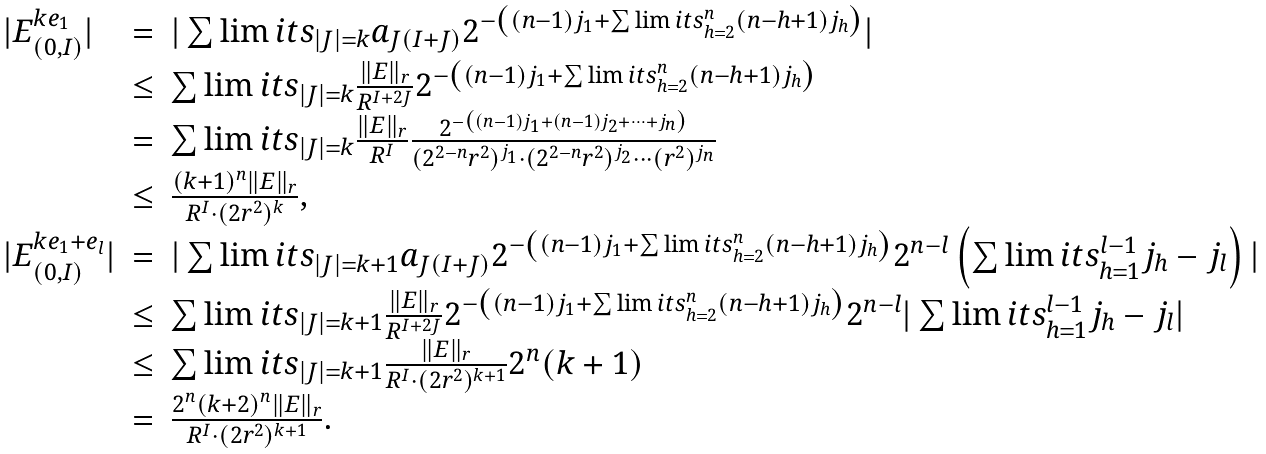Convert formula to latex. <formula><loc_0><loc_0><loc_500><loc_500>\begin{array} { l l l } | E _ { ( 0 , I ) } ^ { k e _ { 1 } } | & = & | \sum \lim i t s _ { | J | = k } a _ { J ( I + J ) } 2 ^ { - \left ( ( n - 1 ) j _ { 1 } + \sum \lim i t s _ { h = 2 } ^ { n } ( n - h + 1 ) j _ { h } \right ) } | \\ & \leq & \sum \lim i t s _ { | J | = k } \frac { \| E \| _ { r } } { R ^ { I + 2 J } } 2 ^ { - \left ( ( n - 1 ) j _ { 1 } + \sum \lim i t s _ { h = 2 } ^ { n } ( n - h + 1 ) j _ { h } \right ) } \\ & = & \sum \lim i t s _ { | J | = k } \frac { \| E \| _ { r } } { R ^ { I } } \frac { 2 ^ { - \left ( ( n - 1 ) j _ { 1 } + ( n - 1 ) j _ { 2 } + \cdots + j _ { n } \right ) } } { ( 2 ^ { 2 - n } r ^ { 2 } ) ^ { j _ { 1 } } \cdot ( 2 ^ { 2 - n } r ^ { 2 } ) ^ { j _ { 2 } } \cdots ( r ^ { 2 } ) ^ { j _ { n } } } \\ & \leq & \frac { ( k + 1 ) ^ { n } \| E \| _ { r } } { R ^ { I } \cdot ( 2 r ^ { 2 } ) ^ { k } } , \\ | E _ { ( 0 , I ) } ^ { k e _ { 1 } + e _ { l } } | & = & | \sum \lim i t s _ { | J | = k + 1 } a _ { J ( I + J ) } 2 ^ { - \left ( ( n - 1 ) j _ { 1 } + \sum \lim i t s _ { h = 2 } ^ { n } ( n - h + 1 ) j _ { h } \right ) } 2 ^ { n - l } \left ( \sum \lim i t s _ { h = 1 } ^ { l - 1 } j _ { h } - j _ { l } \right ) | \\ & \leq & \sum \lim i t s _ { | J | = k + 1 } \frac { \| E \| _ { r } } { R ^ { I + 2 J } } 2 ^ { - \left ( ( n - 1 ) j _ { 1 } + \sum \lim i t s _ { h = 2 } ^ { n } ( n - h + 1 ) j _ { h } \right ) } 2 ^ { n - l } | \sum \lim i t s _ { h = 1 } ^ { l - 1 } j _ { h } - j _ { l } | \\ & \leq & \sum \lim i t s _ { | J | = k + 1 } \frac { \| E \| _ { r } } { R ^ { I } \cdot ( 2 r ^ { 2 } ) ^ { k + 1 } } 2 ^ { n } ( k + 1 ) \\ & = & \frac { 2 ^ { n } ( k + 2 ) ^ { n } \| E \| _ { r } } { R ^ { I } \cdot ( 2 r ^ { 2 } ) ^ { k + 1 } } . \end{array}</formula> 